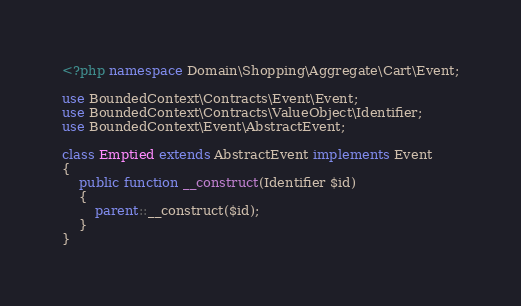Convert code to text. <code><loc_0><loc_0><loc_500><loc_500><_PHP_><?php namespace Domain\Shopping\Aggregate\Cart\Event;

use BoundedContext\Contracts\Event\Event;
use BoundedContext\Contracts\ValueObject\Identifier;
use BoundedContext\Event\AbstractEvent;

class Emptied extends AbstractEvent implements Event
{
    public function __construct(Identifier $id)
    {
        parent::__construct($id);
    }
}
</code> 